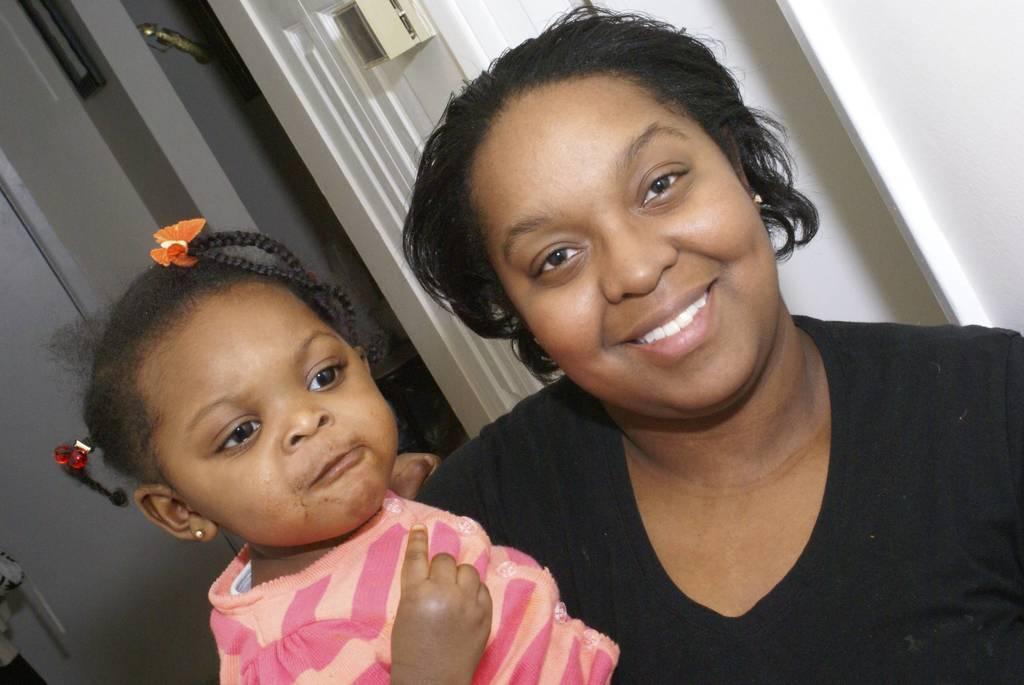Could you give a brief overview of what you see in this image? In this image, we can see a woman standing and she is smiling, she is holding a kid, in the background we can see a door. 